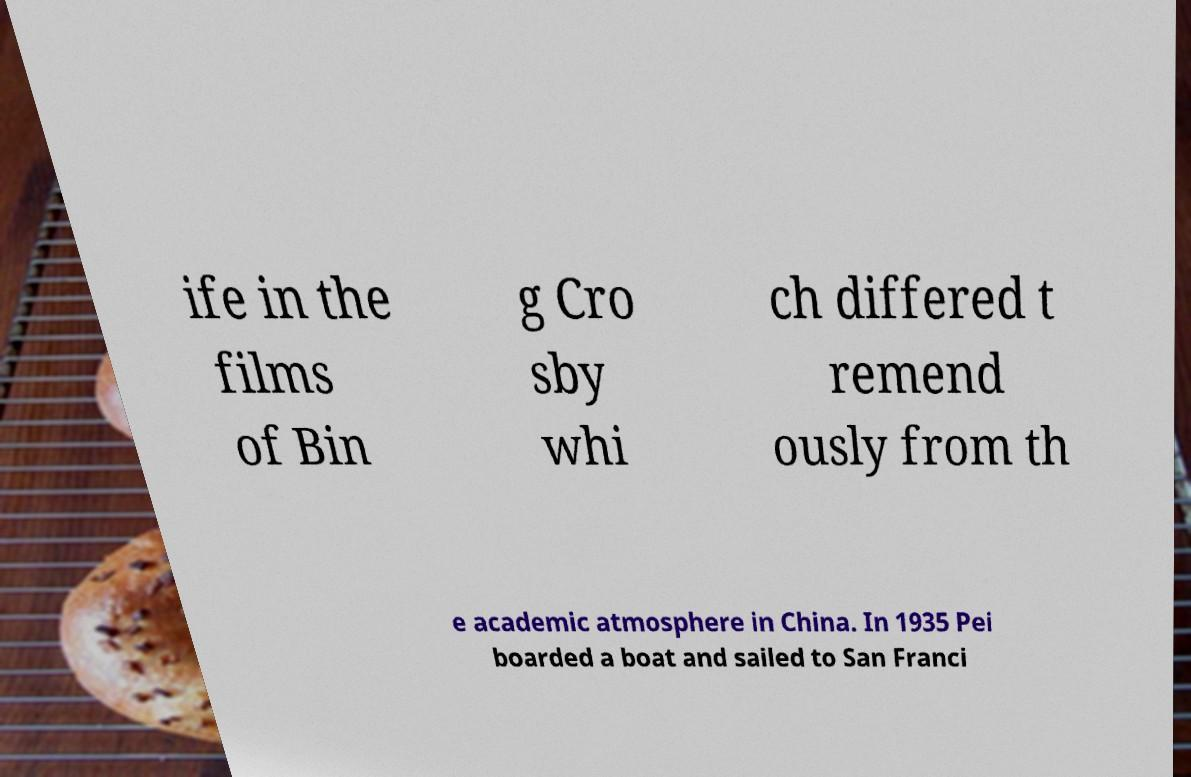There's text embedded in this image that I need extracted. Can you transcribe it verbatim? ife in the films of Bin g Cro sby whi ch differed t remend ously from th e academic atmosphere in China. In 1935 Pei boarded a boat and sailed to San Franci 